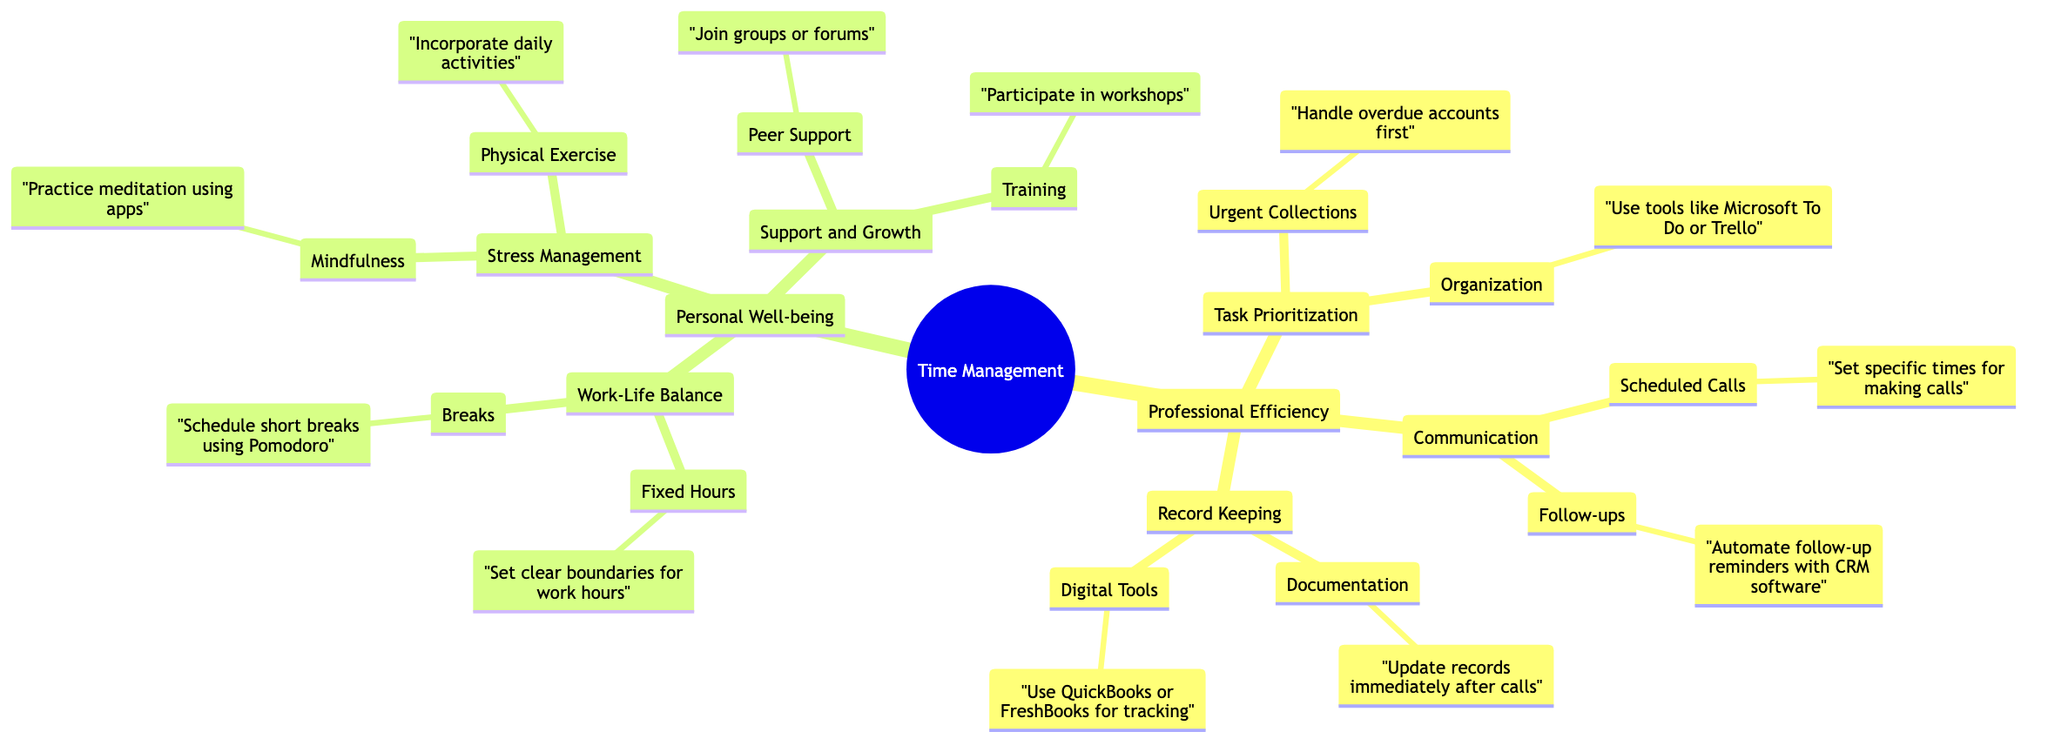What are the two main categories in the mind map? The diagram starts with a root node labeled "Time Management" which branches into two primary nodes labeled "Professional Efficiency" and "Personal Well-being."
Answer: Professional Efficiency, Personal Well-being How many subcategories are under "Professional Efficiency"? Under the "Professional Efficiency" node, there are three subcategories: "Task Prioritization," "Communication," and "Record Keeping." This gives us a total of three.
Answer: 3 What is one tool recommended for task organization? Under the "Organization" subcategory in "Task Prioritization," the mind map suggests using tools like "Microsoft To Do or Trello" for organization.
Answer: Microsoft To Do or Trello What is the suggested practice for stress management? The "Stress Management" section under "Personal Well-being" includes "Mindfulness" as a practice, specifically referencing meditation using apps such as Headspace or Calm.
Answer: Mindfulness What type of breaks are recommended in the "Work-Life Balance" section? The mind map indicates that scheduling "short breaks using techniques like Pomodoro" is advised in the "Breaks" subcategory under "Work-Life Balance."
Answer: short breaks using techniques like Pomodoro What is the primary focus of the "Support and Growth" section? The "Support and Growth" category has two key points: "Peer Support" and "Training," indicating that the focus is on having support systems and opportunities for personal development.
Answer: Peer Support, Training Which software is recommended for follow-up reminders? In the "Follow-ups" subsection under "Communication," the diagram suggests automating follow-up reminders with CRM software like "Salesforce."
Answer: Salesforce Describe a strategy for incorporating physical exercise. Under "Physical Exercise" in "Stress Management," the mind map recommends incorporating daily activities, which implies keeping active through regular movement or exercise routines.
Answer: Incorporate daily activities 